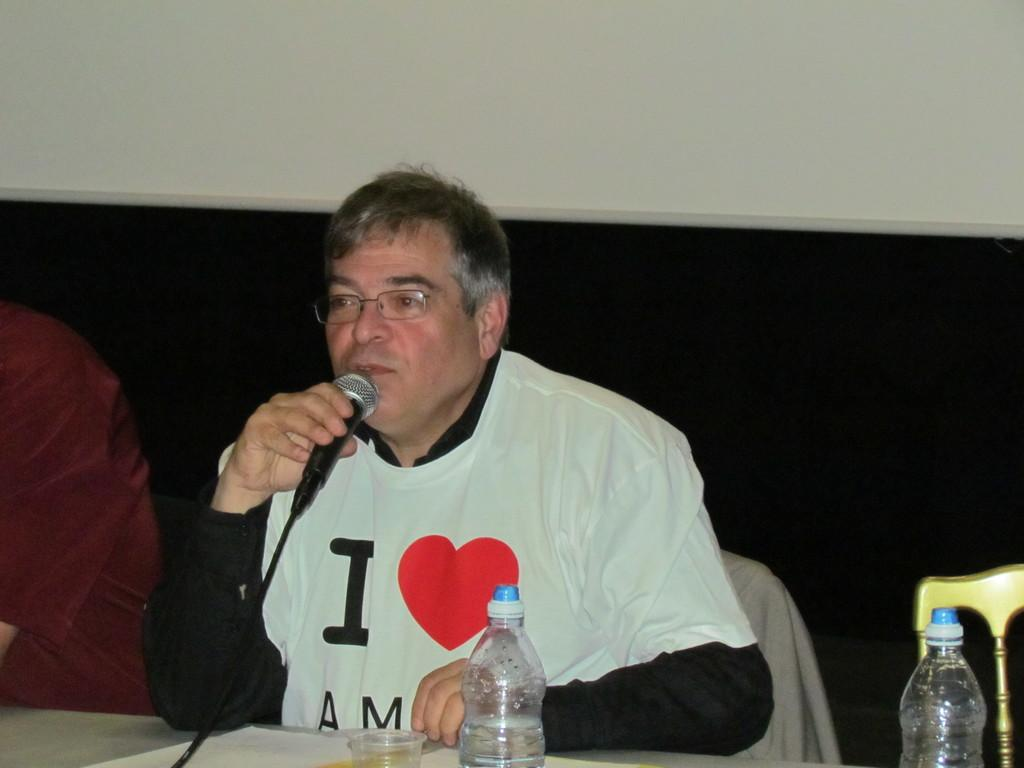What is the main subject of the image? There is a man in the image. What is the man doing in the image? The man is sitting in a chair and speaking into a microphone. What is present on the table in the image? Bottles and a glass are placed on the table. Can you describe the man's position in relation to the table? The man is sitting in a chair, which is likely near the table. What type of birds can be seen flying around the man in the image? There are no birds visible in the image. How does the dust settle on the microphone in the image? There is no dust present in the image, and therefore no dust settling on the microphone. 